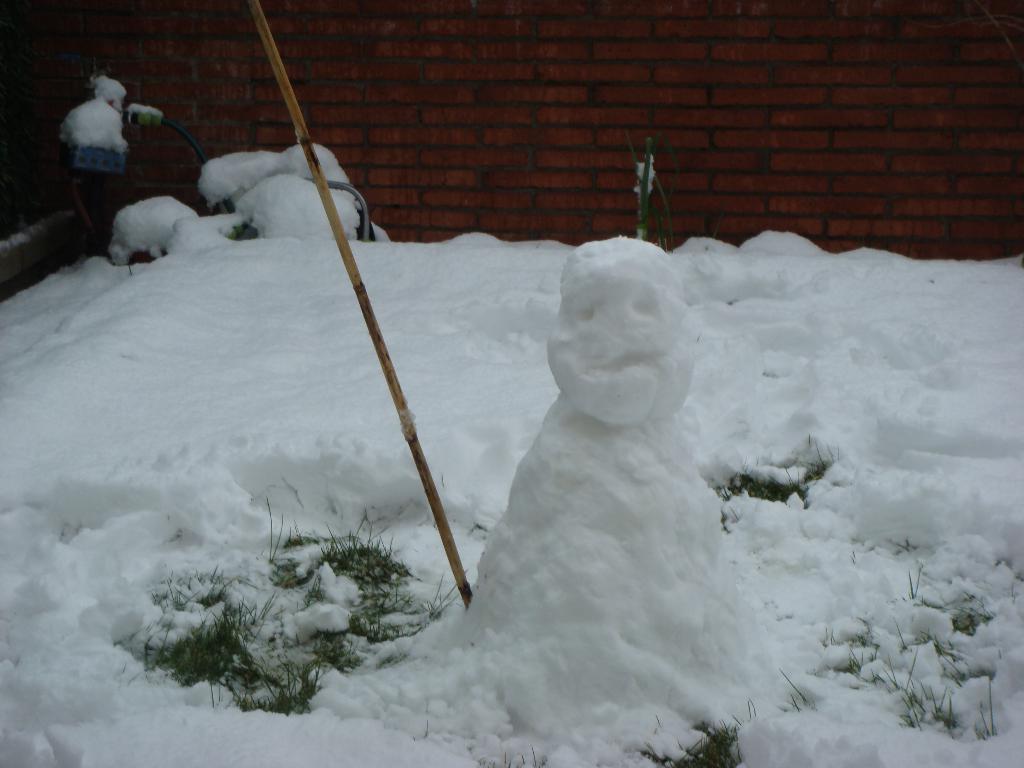Could you give a brief overview of what you see in this image? In the picture we can see a snow surface with some grass and a snow made an idol and a stick and in the background we can see a wall with bricks. 